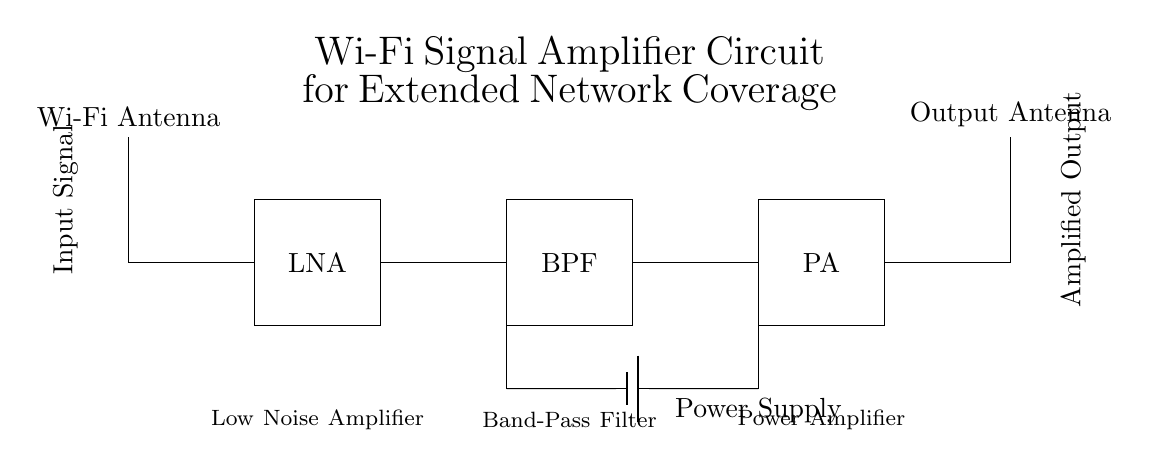What is the purpose of the Low Noise Amplifier? The Low Noise Amplifier (LNA) is used to boost the signal strength while minimizing the addition of noise. It's essential in improving the sensitivity of the circuit, particularly for weak incoming signals.
Answer: boost signal strength What component follows the Band-Pass Filter in this circuit? The output of the Band-Pass Filter (BPF) connects directly to the Power Amplifier (PA). The BPF allows specific frequencies to pass through while attenuating others, preparing the signal for amplification.
Answer: Power Amplifier What is the input to this Wi-Fi signal amplifier? The input signal is received by the Wi-Fi antenna at the beginning of the circuit. This is the first component that collects Wi-Fi signals from the environment to be processed.
Answer: Wi-Fi Antenna Which component can be powered by the battery? The battery provides power to both the Low Noise Amplifier (LNA) and the Power Amplifier (PA) as indicated by the power supply connection in the circuit. The battery is crucial for enabling the amplifiers to function.
Answer: Low Noise Amplifier and Power Amplifier Explain the order of signal processing in the circuit. The signal processing begins with the Wi-Fi antenna, which collects the input signal. Then, the signal is amplified by the LNA, passed through the BPF for frequency selection, and finally amplified again by the PA before being sent to the output antenna. This sequence optimizes the signal for better transmission.
Answer: Wi-Fi Antenna, Low Noise Amplifier, Band-Pass Filter, Power Amplifier, Output Antenna What does PA stand for in this circuit and its role? PA stands for Power Amplifier. Its role is to increase the power level of the signal significantly before it is transmitted out through the output antenna, ensuring that the signal can reach further distances.
Answer: Power Amplifier What is the function of the Band-Pass Filter? The Band-Pass Filter (BPF) serves to allow specific frequency ranges of the signals to pass while blocking others. This filtering is crucial in preparing the signal for effective amplification by the Power Amplifier.
Answer: Allow specific frequencies 